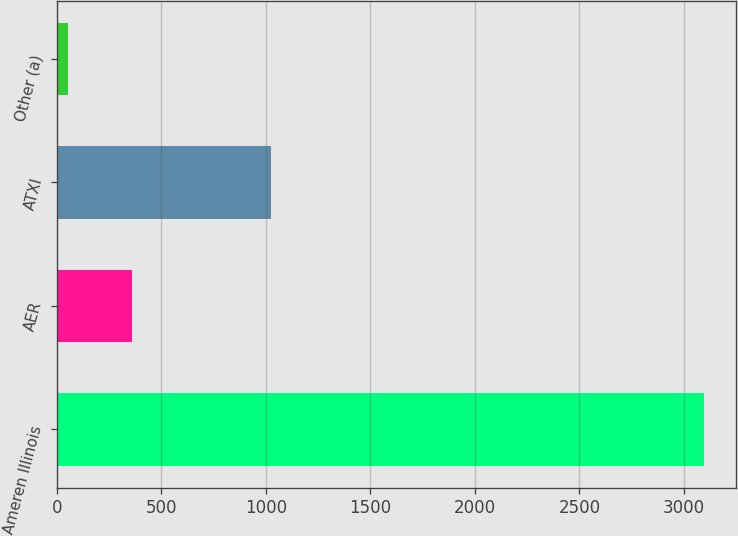Convert chart to OTSL. <chart><loc_0><loc_0><loc_500><loc_500><bar_chart><fcel>Ameren Illinois<fcel>AER<fcel>ATXI<fcel>Other (a)<nl><fcel>3095<fcel>359<fcel>1025<fcel>55<nl></chart> 